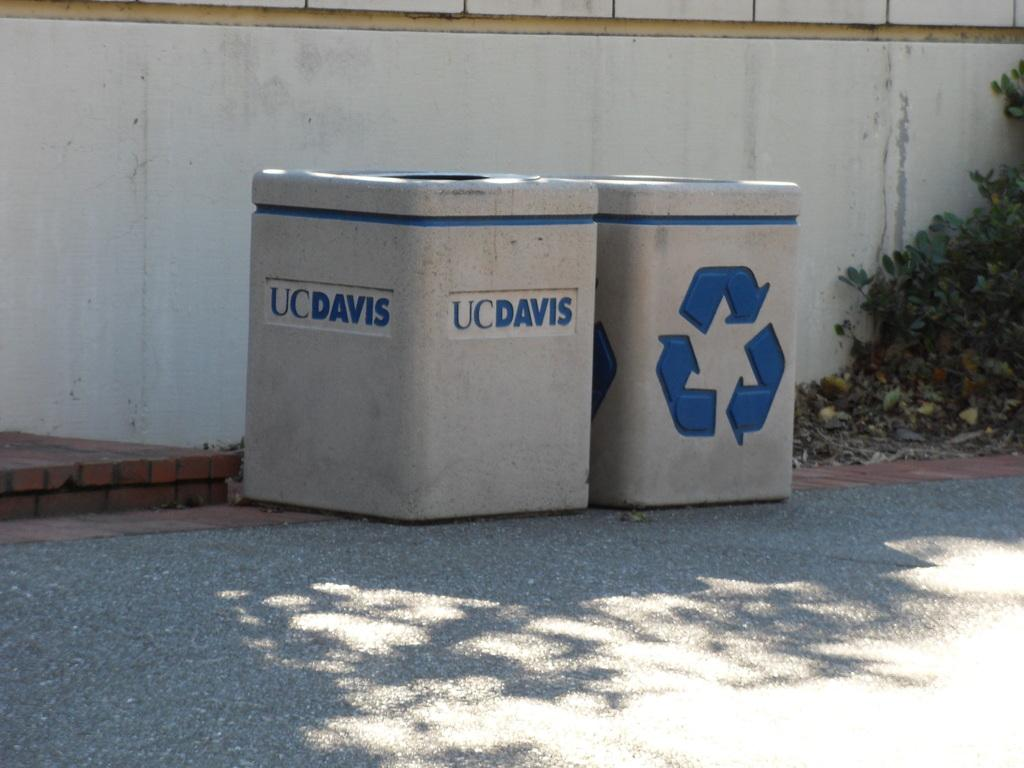<image>
Create a compact narrative representing the image presented. Two UCDavis recycling bins sit on the concrete. 